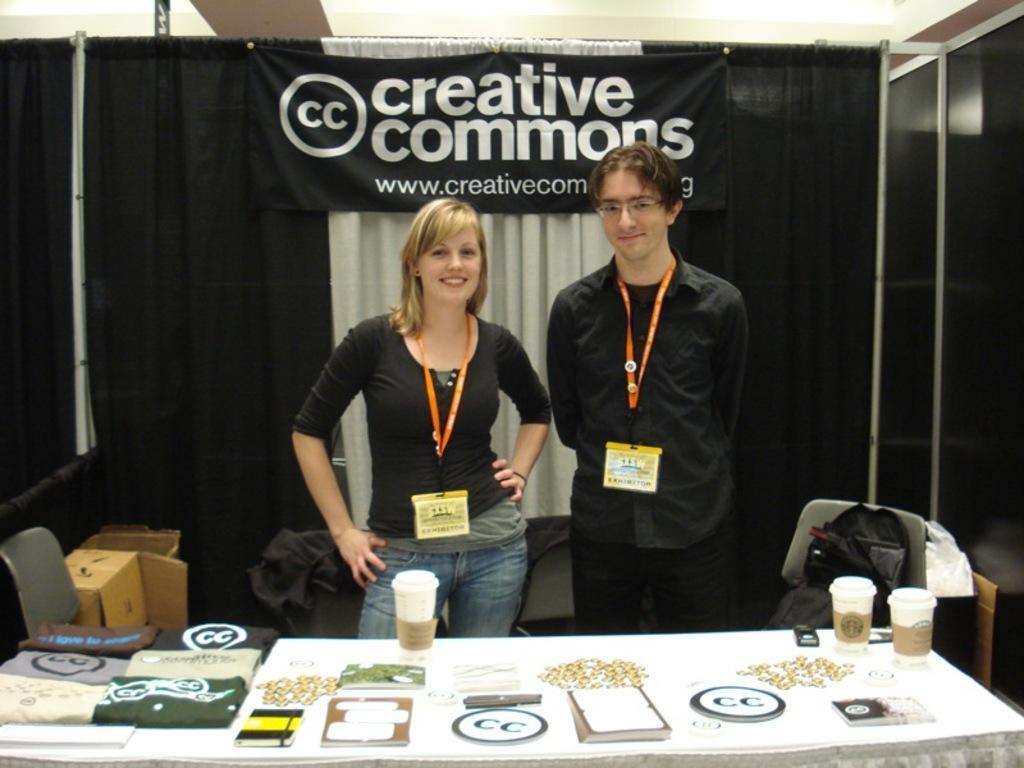Could you give a brief overview of what you see in this image? In this image i can see a woman and a man standing in front of a table. In the table i can see few books, few cups and few other objects. In the background i can see a tent and few cardboard boxes. 